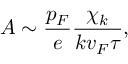Convert formula to latex. <formula><loc_0><loc_0><loc_500><loc_500>A \sim \frac { p _ { F } } { e } \frac { \chi _ { k } } { k v _ { F } \tau } ,</formula> 